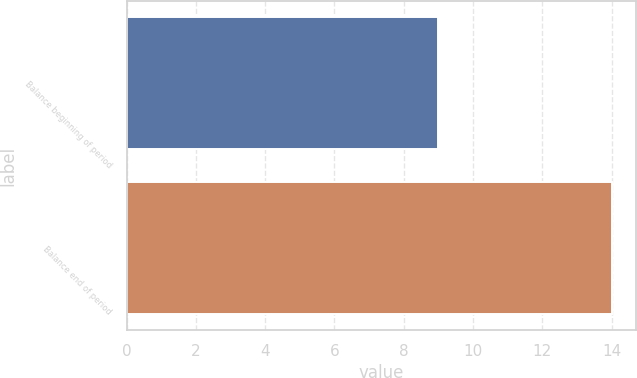Convert chart. <chart><loc_0><loc_0><loc_500><loc_500><bar_chart><fcel>Balance beginning of period<fcel>Balance end of period<nl><fcel>9<fcel>14<nl></chart> 